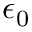<formula> <loc_0><loc_0><loc_500><loc_500>\epsilon _ { 0 }</formula> 